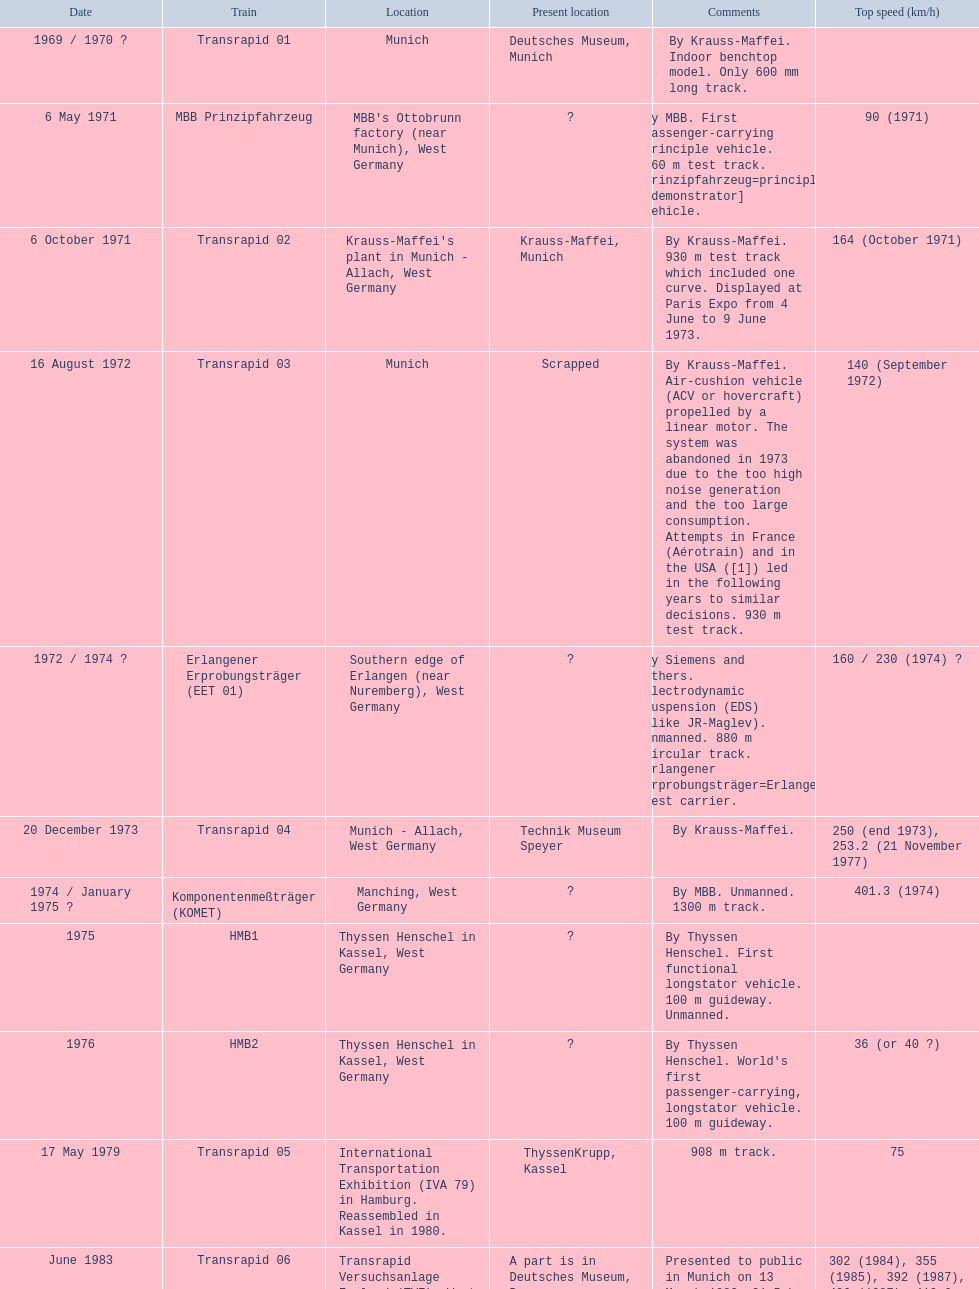Can you identify the only train that has attained a top speed of 500 or higher? Transrapid SMT. 